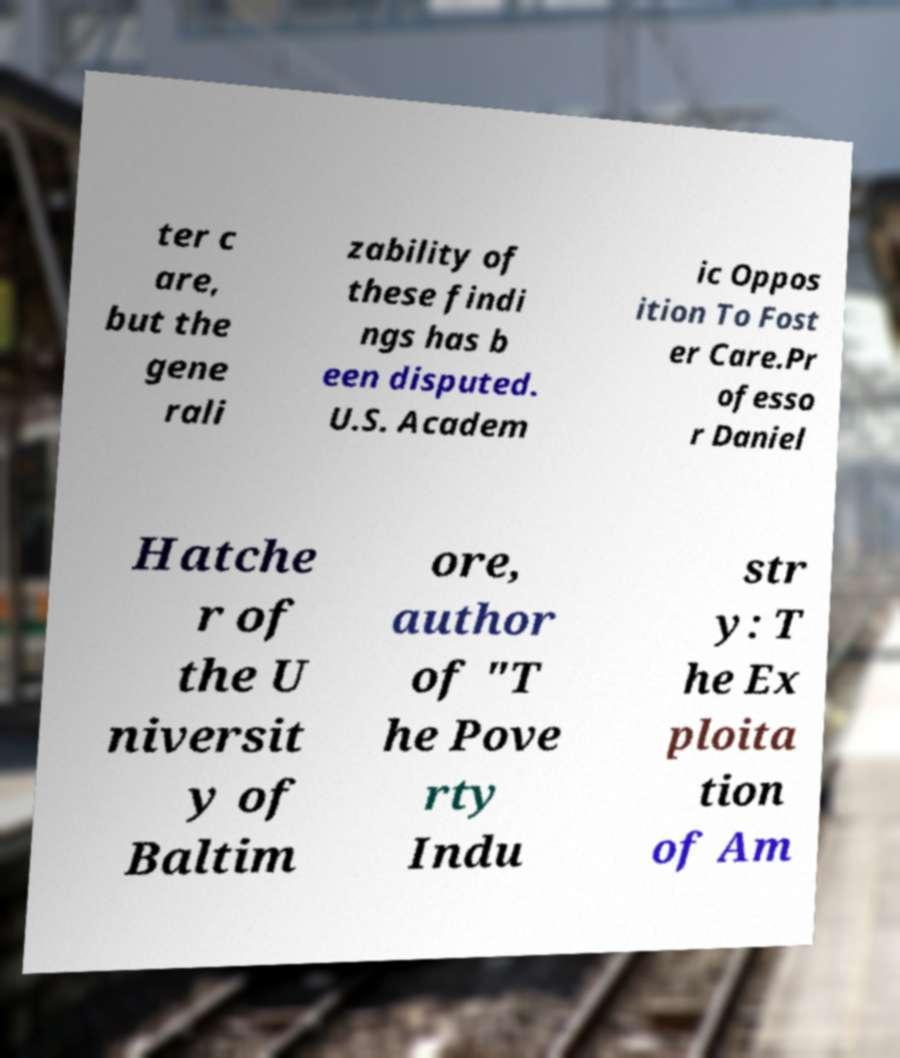I need the written content from this picture converted into text. Can you do that? ter c are, but the gene rali zability of these findi ngs has b een disputed. U.S. Academ ic Oppos ition To Fost er Care.Pr ofesso r Daniel Hatche r of the U niversit y of Baltim ore, author of "T he Pove rty Indu str y: T he Ex ploita tion of Am 